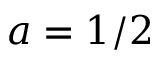<formula> <loc_0><loc_0><loc_500><loc_500>a = 1 / 2</formula> 